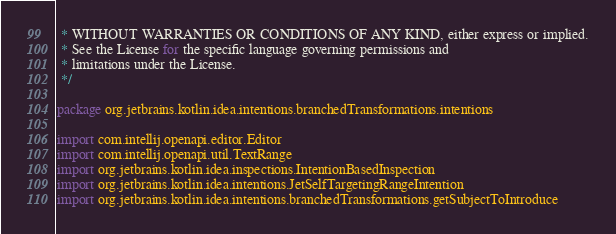Convert code to text. <code><loc_0><loc_0><loc_500><loc_500><_Kotlin_> * WITHOUT WARRANTIES OR CONDITIONS OF ANY KIND, either express or implied.
 * See the License for the specific language governing permissions and
 * limitations under the License.
 */

package org.jetbrains.kotlin.idea.intentions.branchedTransformations.intentions

import com.intellij.openapi.editor.Editor
import com.intellij.openapi.util.TextRange
import org.jetbrains.kotlin.idea.inspections.IntentionBasedInspection
import org.jetbrains.kotlin.idea.intentions.JetSelfTargetingRangeIntention
import org.jetbrains.kotlin.idea.intentions.branchedTransformations.getSubjectToIntroduce</code> 